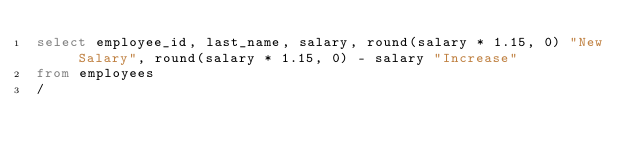<code> <loc_0><loc_0><loc_500><loc_500><_SQL_>select employee_id, last_name, salary, round(salary * 1.15, 0) "New Salary", round(salary * 1.15, 0) - salary "Increase"
from employees
/
</code> 